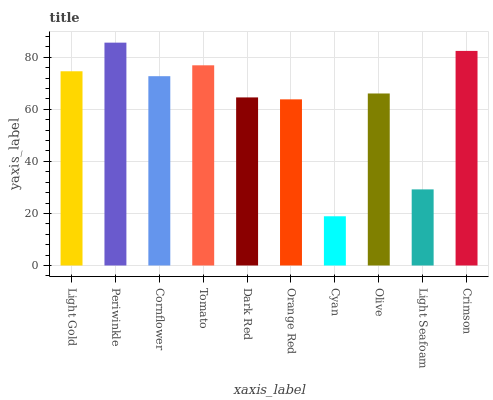Is Cyan the minimum?
Answer yes or no. Yes. Is Periwinkle the maximum?
Answer yes or no. Yes. Is Cornflower the minimum?
Answer yes or no. No. Is Cornflower the maximum?
Answer yes or no. No. Is Periwinkle greater than Cornflower?
Answer yes or no. Yes. Is Cornflower less than Periwinkle?
Answer yes or no. Yes. Is Cornflower greater than Periwinkle?
Answer yes or no. No. Is Periwinkle less than Cornflower?
Answer yes or no. No. Is Cornflower the high median?
Answer yes or no. Yes. Is Olive the low median?
Answer yes or no. Yes. Is Light Gold the high median?
Answer yes or no. No. Is Light Seafoam the low median?
Answer yes or no. No. 